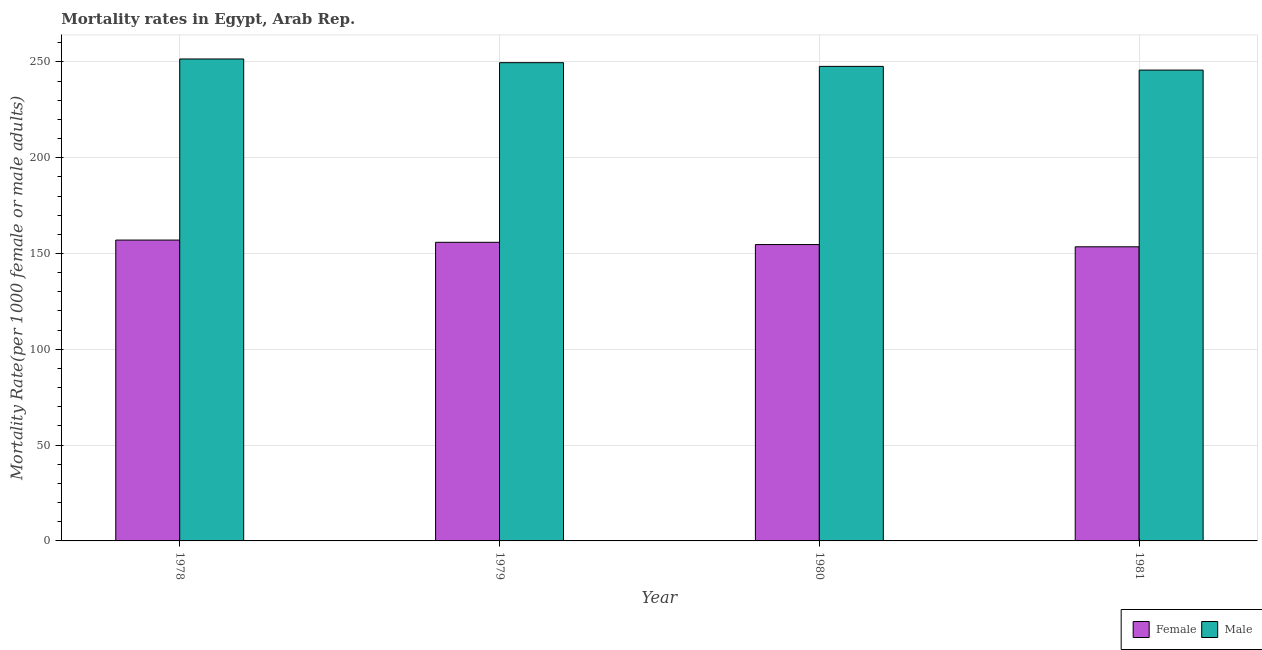How many groups of bars are there?
Your answer should be compact. 4. How many bars are there on the 2nd tick from the left?
Ensure brevity in your answer.  2. How many bars are there on the 1st tick from the right?
Offer a terse response. 2. What is the label of the 2nd group of bars from the left?
Make the answer very short. 1979. In how many cases, is the number of bars for a given year not equal to the number of legend labels?
Ensure brevity in your answer.  0. What is the male mortality rate in 1980?
Your response must be concise. 247.67. Across all years, what is the maximum female mortality rate?
Provide a short and direct response. 157.02. Across all years, what is the minimum male mortality rate?
Provide a short and direct response. 245.74. In which year was the male mortality rate maximum?
Give a very brief answer. 1978. What is the total male mortality rate in the graph?
Your response must be concise. 994.55. What is the difference between the female mortality rate in 1979 and that in 1980?
Your answer should be very brief. 1.17. What is the difference between the female mortality rate in 1981 and the male mortality rate in 1978?
Offer a terse response. -3.51. What is the average male mortality rate per year?
Provide a short and direct response. 248.64. In the year 1979, what is the difference between the female mortality rate and male mortality rate?
Offer a very short reply. 0. What is the ratio of the male mortality rate in 1978 to that in 1980?
Your answer should be very brief. 1.02. Is the male mortality rate in 1978 less than that in 1980?
Your answer should be very brief. No. What is the difference between the highest and the second highest male mortality rate?
Your answer should be very brief. 1.93. What is the difference between the highest and the lowest female mortality rate?
Offer a terse response. 3.51. In how many years, is the female mortality rate greater than the average female mortality rate taken over all years?
Offer a very short reply. 2. What does the 2nd bar from the right in 1980 represents?
Offer a very short reply. Female. Are all the bars in the graph horizontal?
Your response must be concise. No. How many years are there in the graph?
Ensure brevity in your answer.  4. What is the difference between two consecutive major ticks on the Y-axis?
Your answer should be very brief. 50. Are the values on the major ticks of Y-axis written in scientific E-notation?
Ensure brevity in your answer.  No. Where does the legend appear in the graph?
Keep it short and to the point. Bottom right. What is the title of the graph?
Keep it short and to the point. Mortality rates in Egypt, Arab Rep. What is the label or title of the Y-axis?
Make the answer very short. Mortality Rate(per 1000 female or male adults). What is the Mortality Rate(per 1000 female or male adults) of Female in 1978?
Provide a succinct answer. 157.02. What is the Mortality Rate(per 1000 female or male adults) in Male in 1978?
Make the answer very short. 251.54. What is the Mortality Rate(per 1000 female or male adults) of Female in 1979?
Give a very brief answer. 155.85. What is the Mortality Rate(per 1000 female or male adults) in Male in 1979?
Give a very brief answer. 249.6. What is the Mortality Rate(per 1000 female or male adults) of Female in 1980?
Provide a short and direct response. 154.68. What is the Mortality Rate(per 1000 female or male adults) of Male in 1980?
Make the answer very short. 247.67. What is the Mortality Rate(per 1000 female or male adults) of Female in 1981?
Offer a very short reply. 153.51. What is the Mortality Rate(per 1000 female or male adults) of Male in 1981?
Ensure brevity in your answer.  245.74. Across all years, what is the maximum Mortality Rate(per 1000 female or male adults) of Female?
Offer a terse response. 157.02. Across all years, what is the maximum Mortality Rate(per 1000 female or male adults) in Male?
Provide a short and direct response. 251.54. Across all years, what is the minimum Mortality Rate(per 1000 female or male adults) of Female?
Offer a terse response. 153.51. Across all years, what is the minimum Mortality Rate(per 1000 female or male adults) in Male?
Give a very brief answer. 245.74. What is the total Mortality Rate(per 1000 female or male adults) of Female in the graph?
Give a very brief answer. 621.07. What is the total Mortality Rate(per 1000 female or male adults) of Male in the graph?
Provide a succinct answer. 994.55. What is the difference between the Mortality Rate(per 1000 female or male adults) in Female in 1978 and that in 1979?
Offer a very short reply. 1.17. What is the difference between the Mortality Rate(per 1000 female or male adults) of Male in 1978 and that in 1979?
Make the answer very short. 1.93. What is the difference between the Mortality Rate(per 1000 female or male adults) of Female in 1978 and that in 1980?
Make the answer very short. 2.34. What is the difference between the Mortality Rate(per 1000 female or male adults) of Male in 1978 and that in 1980?
Offer a terse response. 3.87. What is the difference between the Mortality Rate(per 1000 female or male adults) in Female in 1978 and that in 1981?
Offer a terse response. 3.51. What is the difference between the Mortality Rate(per 1000 female or male adults) in Male in 1978 and that in 1981?
Your answer should be very brief. 5.8. What is the difference between the Mortality Rate(per 1000 female or male adults) in Female in 1979 and that in 1980?
Your answer should be compact. 1.17. What is the difference between the Mortality Rate(per 1000 female or male adults) in Male in 1979 and that in 1980?
Your answer should be compact. 1.93. What is the difference between the Mortality Rate(per 1000 female or male adults) of Female in 1979 and that in 1981?
Give a very brief answer. 2.34. What is the difference between the Mortality Rate(per 1000 female or male adults) of Male in 1979 and that in 1981?
Ensure brevity in your answer.  3.87. What is the difference between the Mortality Rate(per 1000 female or male adults) of Female in 1980 and that in 1981?
Make the answer very short. 1.17. What is the difference between the Mortality Rate(per 1000 female or male adults) of Male in 1980 and that in 1981?
Make the answer very short. 1.93. What is the difference between the Mortality Rate(per 1000 female or male adults) of Female in 1978 and the Mortality Rate(per 1000 female or male adults) of Male in 1979?
Ensure brevity in your answer.  -92.58. What is the difference between the Mortality Rate(per 1000 female or male adults) in Female in 1978 and the Mortality Rate(per 1000 female or male adults) in Male in 1980?
Provide a succinct answer. -90.65. What is the difference between the Mortality Rate(per 1000 female or male adults) in Female in 1978 and the Mortality Rate(per 1000 female or male adults) in Male in 1981?
Give a very brief answer. -88.72. What is the difference between the Mortality Rate(per 1000 female or male adults) of Female in 1979 and the Mortality Rate(per 1000 female or male adults) of Male in 1980?
Your answer should be compact. -91.82. What is the difference between the Mortality Rate(per 1000 female or male adults) of Female in 1979 and the Mortality Rate(per 1000 female or male adults) of Male in 1981?
Ensure brevity in your answer.  -89.89. What is the difference between the Mortality Rate(per 1000 female or male adults) of Female in 1980 and the Mortality Rate(per 1000 female or male adults) of Male in 1981?
Provide a short and direct response. -91.06. What is the average Mortality Rate(per 1000 female or male adults) in Female per year?
Keep it short and to the point. 155.27. What is the average Mortality Rate(per 1000 female or male adults) of Male per year?
Provide a succinct answer. 248.64. In the year 1978, what is the difference between the Mortality Rate(per 1000 female or male adults) in Female and Mortality Rate(per 1000 female or male adults) in Male?
Keep it short and to the point. -94.51. In the year 1979, what is the difference between the Mortality Rate(per 1000 female or male adults) in Female and Mortality Rate(per 1000 female or male adults) in Male?
Your answer should be compact. -93.75. In the year 1980, what is the difference between the Mortality Rate(per 1000 female or male adults) of Female and Mortality Rate(per 1000 female or male adults) of Male?
Provide a succinct answer. -92.99. In the year 1981, what is the difference between the Mortality Rate(per 1000 female or male adults) in Female and Mortality Rate(per 1000 female or male adults) in Male?
Your answer should be very brief. -92.23. What is the ratio of the Mortality Rate(per 1000 female or male adults) of Female in 1978 to that in 1979?
Offer a terse response. 1.01. What is the ratio of the Mortality Rate(per 1000 female or male adults) in Male in 1978 to that in 1979?
Your answer should be compact. 1.01. What is the ratio of the Mortality Rate(per 1000 female or male adults) in Female in 1978 to that in 1980?
Keep it short and to the point. 1.02. What is the ratio of the Mortality Rate(per 1000 female or male adults) in Male in 1978 to that in 1980?
Offer a very short reply. 1.02. What is the ratio of the Mortality Rate(per 1000 female or male adults) of Female in 1978 to that in 1981?
Offer a terse response. 1.02. What is the ratio of the Mortality Rate(per 1000 female or male adults) in Male in 1978 to that in 1981?
Offer a very short reply. 1.02. What is the ratio of the Mortality Rate(per 1000 female or male adults) in Female in 1979 to that in 1980?
Ensure brevity in your answer.  1.01. What is the ratio of the Mortality Rate(per 1000 female or male adults) in Female in 1979 to that in 1981?
Provide a succinct answer. 1.02. What is the ratio of the Mortality Rate(per 1000 female or male adults) of Male in 1979 to that in 1981?
Keep it short and to the point. 1.02. What is the ratio of the Mortality Rate(per 1000 female or male adults) in Female in 1980 to that in 1981?
Your response must be concise. 1.01. What is the ratio of the Mortality Rate(per 1000 female or male adults) in Male in 1980 to that in 1981?
Offer a terse response. 1.01. What is the difference between the highest and the second highest Mortality Rate(per 1000 female or male adults) of Female?
Offer a very short reply. 1.17. What is the difference between the highest and the second highest Mortality Rate(per 1000 female or male adults) in Male?
Your response must be concise. 1.93. What is the difference between the highest and the lowest Mortality Rate(per 1000 female or male adults) in Female?
Give a very brief answer. 3.51. What is the difference between the highest and the lowest Mortality Rate(per 1000 female or male adults) of Male?
Provide a short and direct response. 5.8. 